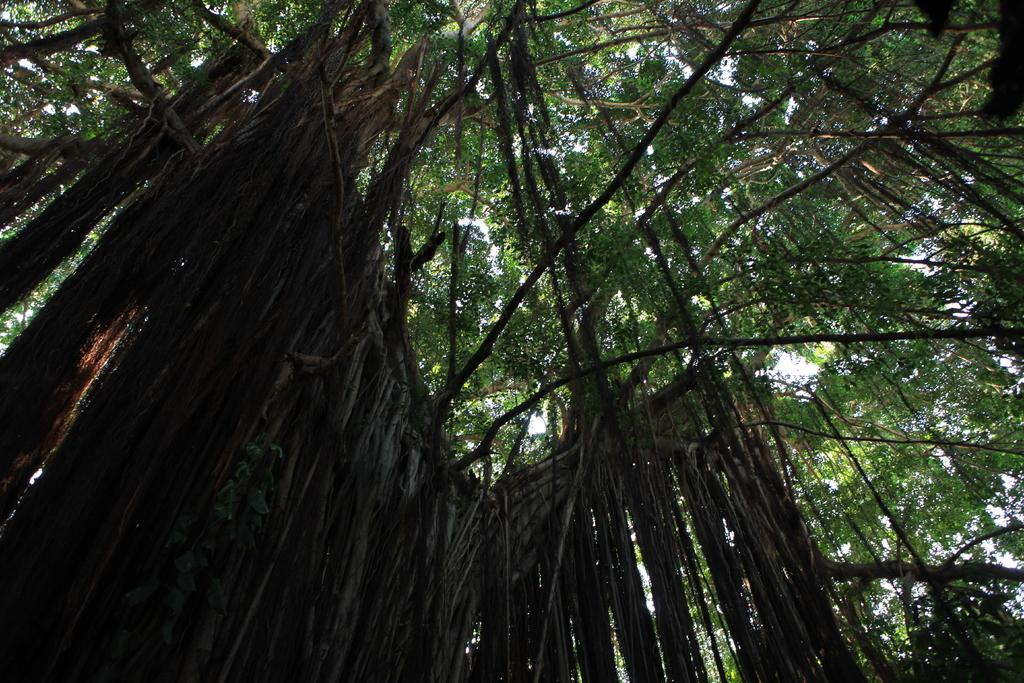What type of vegetation can be seen in the image? There are trees in the image. What part of the natural environment is visible in the image? The sky is visible in the background of the image. What type of underwear is hanging on the trees in the image? There is no underwear present in the image; it only features trees and the sky. 